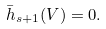<formula> <loc_0><loc_0><loc_500><loc_500>\bar { h } _ { s + 1 } ( V ) = 0 .</formula> 